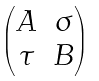<formula> <loc_0><loc_0><loc_500><loc_500>\begin{pmatrix} A & \sigma \\ \tau & B \end{pmatrix}</formula> 